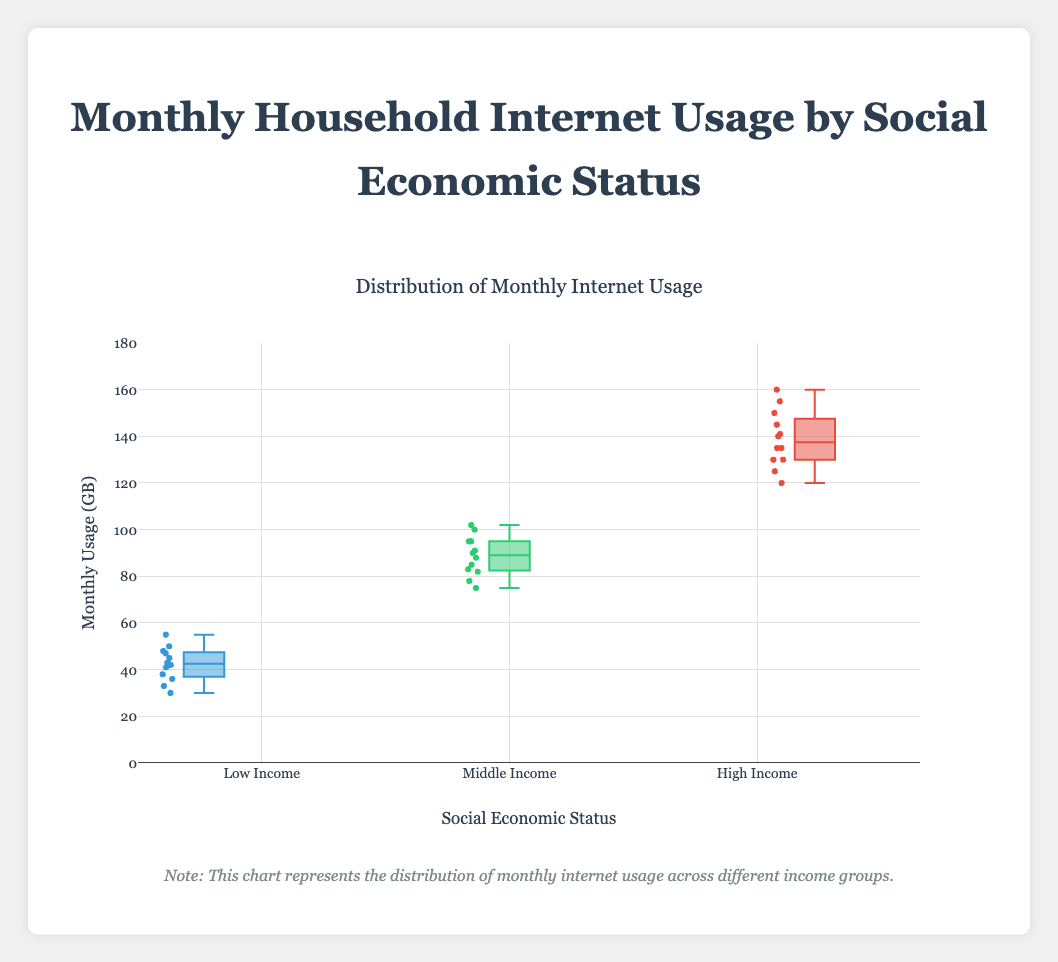What is the title of the figure? The title is located at the top center of the figure and reads: "Distribution of Monthly Internet Usage"
Answer: Distribution of Monthly Internet Usage What is the median value for the Low Income group? The median value is the line inside the box for the Low Income group. Estimate its position on the y-axis.
Answer: 42 Which group has the highest maximum monthly usage? Look for the highest point in the figure and identify which group it belongs to.
Answer: High Income What is the range of monthly usage for the Middle Income group? The range is the difference between the maximum and minimum values in the Middle Income group box plot.
Answer: 102 - 75 = 27 Which group has the smallest interquartile range (IQR)? The IQR is the height of the box. Compare the height of the boxes across different groups.
Answer: Low Income What is the approximate lower quartile (Q1) for the High Income group? The lower quartile (Q1) is the bottom of the box for the High Income group. Estimate its position on the y-axis.
Answer: 130 Which group shows more variability in monthly usage, Middle Income or Low Income? Compare the overall spread (range and IQR) of the Middle Income and Low Income group box plots.
Answer: Middle Income How does the median monthly usage compare between Middle Income and High Income groups? Compare the line inside the box for each group to see which one is higher.
Answer: The median for High Income is higher than Middle Income Is there any group with an outlier monthly usage value? Outliers are represented as individual points outside the "whiskers" of the box plot. Check if any groups have such points.
Answer: No What does the Note below the chart inform about? Read the note below the chart to understand its purpose and message regarding the data.
Answer: It specifies that the chart represents the distribution of monthly internet usage across different income groups 